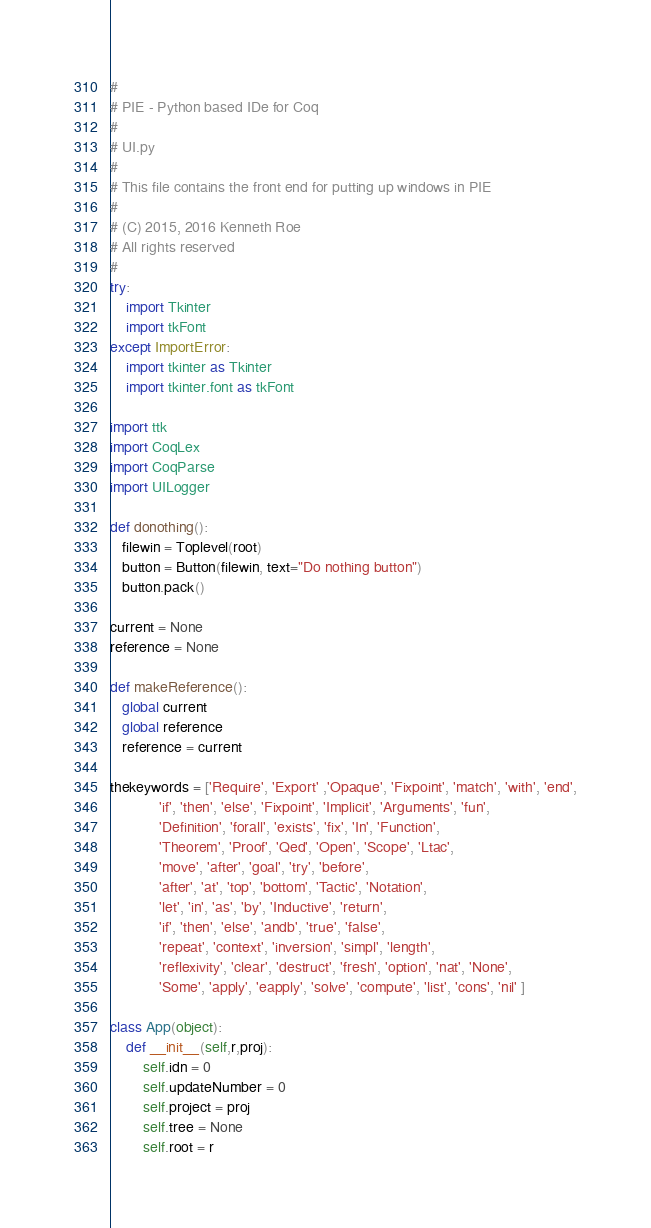<code> <loc_0><loc_0><loc_500><loc_500><_Python_>#
# PIE - Python based IDe for Coq
#
# UI.py
#
# This file contains the front end for putting up windows in PIE
#
# (C) 2015, 2016 Kenneth Roe
# All rights reserved
#
try:
    import Tkinter
    import tkFont
except ImportError:
    import tkinter as Tkinter
    import tkinter.font as tkFont

import ttk
import CoqLex
import CoqParse
import UILogger

def donothing():
   filewin = Toplevel(root)
   button = Button(filewin, text="Do nothing button")
   button.pack()

current = None
reference = None
 
def makeReference():
   global current
   global reference
   reference = current

thekeywords = ['Require', 'Export' ,'Opaque', 'Fixpoint', 'match', 'with', 'end',
            'if', 'then', 'else', 'Fixpoint', 'Implicit', 'Arguments', 'fun',
            'Definition', 'forall', 'exists', 'fix', 'In', 'Function',
            'Theorem', 'Proof', 'Qed', 'Open', 'Scope', 'Ltac',
            'move', 'after', 'goal', 'try', 'before',
            'after', 'at', 'top', 'bottom', 'Tactic', 'Notation',
            'let', 'in', 'as', 'by', 'Inductive', 'return',
            'if', 'then', 'else', 'andb', 'true', 'false',
            'repeat', 'context', 'inversion', 'simpl', 'length',
            'reflexivity', 'clear', 'destruct', 'fresh', 'option', 'nat', 'None',
            'Some', 'apply', 'eapply', 'solve', 'compute', 'list', 'cons', 'nil' ]

class App(object):
    def __init__(self,r,proj):
        self.idn = 0
        self.updateNumber = 0
        self.project = proj
        self.tree = None
        self.root = r</code> 